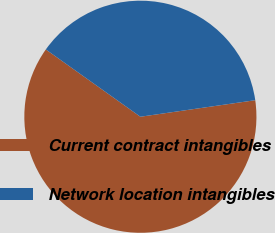Convert chart to OTSL. <chart><loc_0><loc_0><loc_500><loc_500><pie_chart><fcel>Current contract intangibles<fcel>Network location intangibles<nl><fcel>62.12%<fcel>37.88%<nl></chart> 